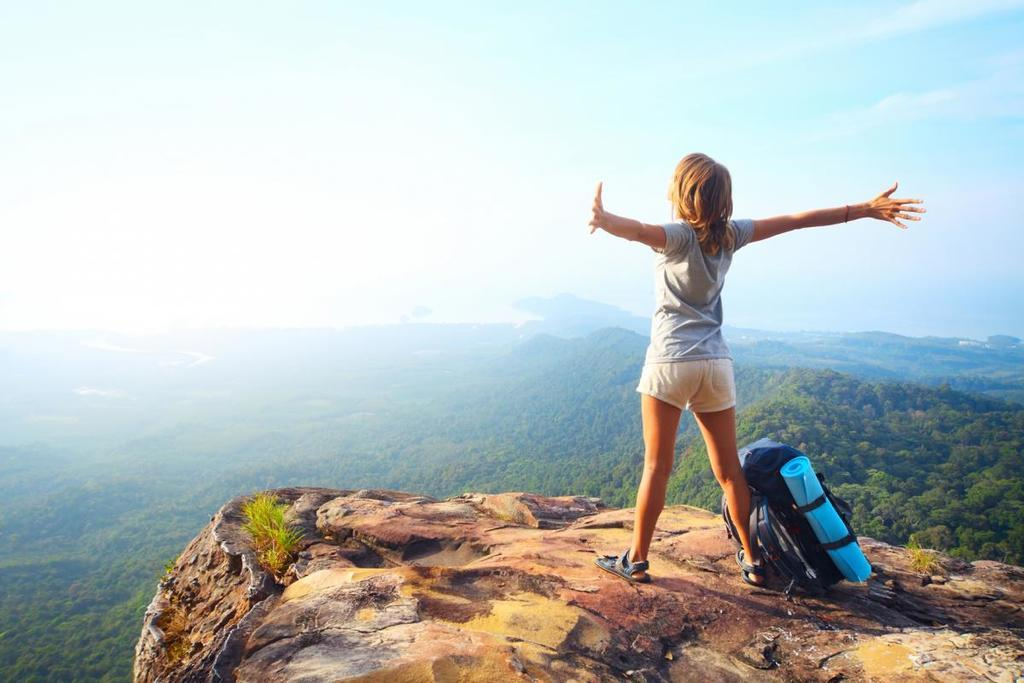What is the woman doing in the image? The woman is standing on a hill in the image. What object is beside the woman? The woman has a backpack beside her. What can be seen in the background of the image? Sky, clouds, trees, and hills are visible in the background of the image. What type of science experiment is being conducted with the box and branch in the image? There is no box or branch present in the image, and therefore no science experiment can be observed. 